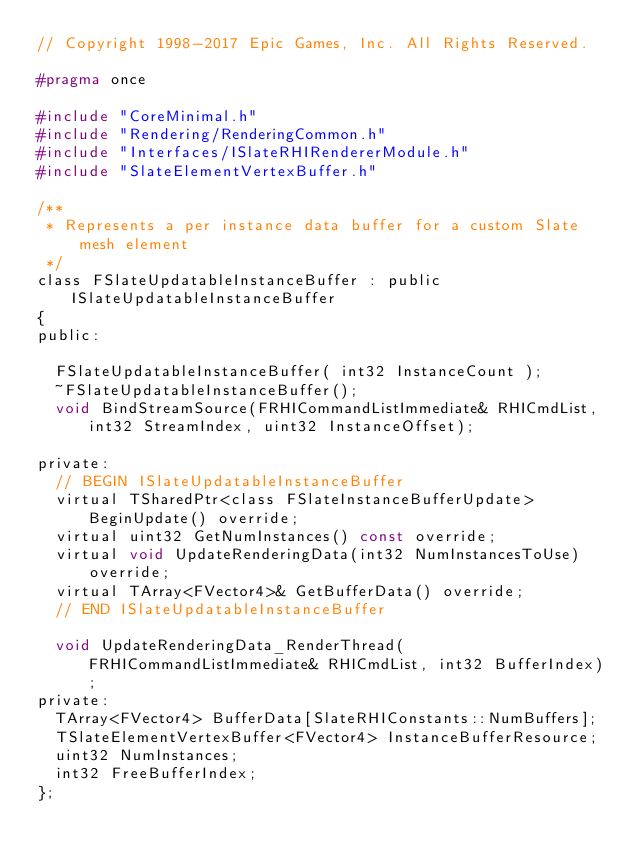Convert code to text. <code><loc_0><loc_0><loc_500><loc_500><_C_>// Copyright 1998-2017 Epic Games, Inc. All Rights Reserved.

#pragma once

#include "CoreMinimal.h"
#include "Rendering/RenderingCommon.h"
#include "Interfaces/ISlateRHIRendererModule.h"
#include "SlateElementVertexBuffer.h"

/**
 * Represents a per instance data buffer for a custom Slate mesh element
 */
class FSlateUpdatableInstanceBuffer : public ISlateUpdatableInstanceBuffer
{
public:

	FSlateUpdatableInstanceBuffer( int32 InstanceCount );
	~FSlateUpdatableInstanceBuffer();
	void BindStreamSource(FRHICommandListImmediate& RHICmdList, int32 StreamIndex, uint32 InstanceOffset);

private:
	// BEGIN ISlateUpdatableInstanceBuffer
	virtual TSharedPtr<class FSlateInstanceBufferUpdate> BeginUpdate() override;
	virtual uint32 GetNumInstances() const override;
	virtual void UpdateRenderingData(int32 NumInstancesToUse) override;
	virtual TArray<FVector4>& GetBufferData() override;
	// END ISlateUpdatableInstanceBuffer

	void UpdateRenderingData_RenderThread(FRHICommandListImmediate& RHICmdList, int32 BufferIndex);
private:
	TArray<FVector4> BufferData[SlateRHIConstants::NumBuffers];
	TSlateElementVertexBuffer<FVector4> InstanceBufferResource;
	uint32 NumInstances;
	int32 FreeBufferIndex;
};



</code> 